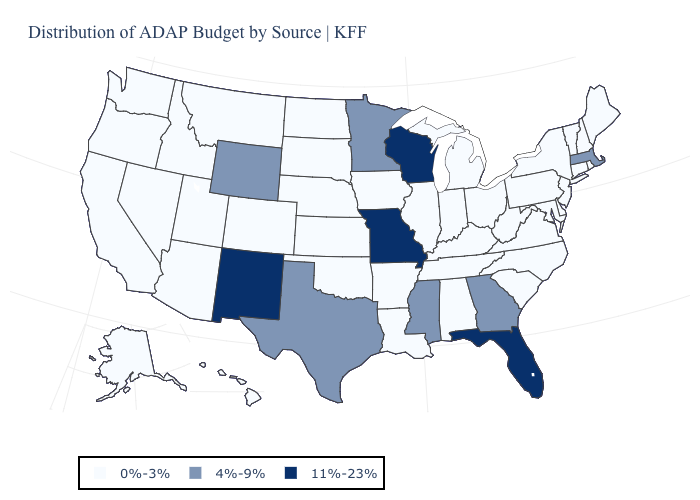What is the value of West Virginia?
Write a very short answer. 0%-3%. Name the states that have a value in the range 0%-3%?
Write a very short answer. Alabama, Alaska, Arizona, Arkansas, California, Colorado, Connecticut, Delaware, Hawaii, Idaho, Illinois, Indiana, Iowa, Kansas, Kentucky, Louisiana, Maine, Maryland, Michigan, Montana, Nebraska, Nevada, New Hampshire, New Jersey, New York, North Carolina, North Dakota, Ohio, Oklahoma, Oregon, Pennsylvania, Rhode Island, South Carolina, South Dakota, Tennessee, Utah, Vermont, Virginia, Washington, West Virginia. Does the first symbol in the legend represent the smallest category?
Give a very brief answer. Yes. Name the states that have a value in the range 11%-23%?
Keep it brief. Florida, Missouri, New Mexico, Wisconsin. What is the lowest value in states that border North Dakota?
Quick response, please. 0%-3%. Does Indiana have the lowest value in the MidWest?
Quick response, please. Yes. Is the legend a continuous bar?
Write a very short answer. No. What is the highest value in the MidWest ?
Quick response, please. 11%-23%. Name the states that have a value in the range 4%-9%?
Concise answer only. Georgia, Massachusetts, Minnesota, Mississippi, Texas, Wyoming. Name the states that have a value in the range 0%-3%?
Be succinct. Alabama, Alaska, Arizona, Arkansas, California, Colorado, Connecticut, Delaware, Hawaii, Idaho, Illinois, Indiana, Iowa, Kansas, Kentucky, Louisiana, Maine, Maryland, Michigan, Montana, Nebraska, Nevada, New Hampshire, New Jersey, New York, North Carolina, North Dakota, Ohio, Oklahoma, Oregon, Pennsylvania, Rhode Island, South Carolina, South Dakota, Tennessee, Utah, Vermont, Virginia, Washington, West Virginia. What is the value of Hawaii?
Quick response, please. 0%-3%. Does South Carolina have a higher value than Montana?
Answer briefly. No. What is the highest value in the USA?
Be succinct. 11%-23%. Does Missouri have the lowest value in the MidWest?
Answer briefly. No. What is the value of Oregon?
Be succinct. 0%-3%. 